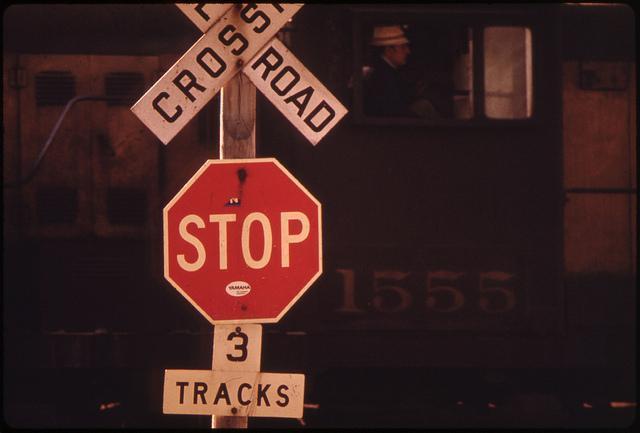How many tracks are there?
Give a very brief answer. 3. 